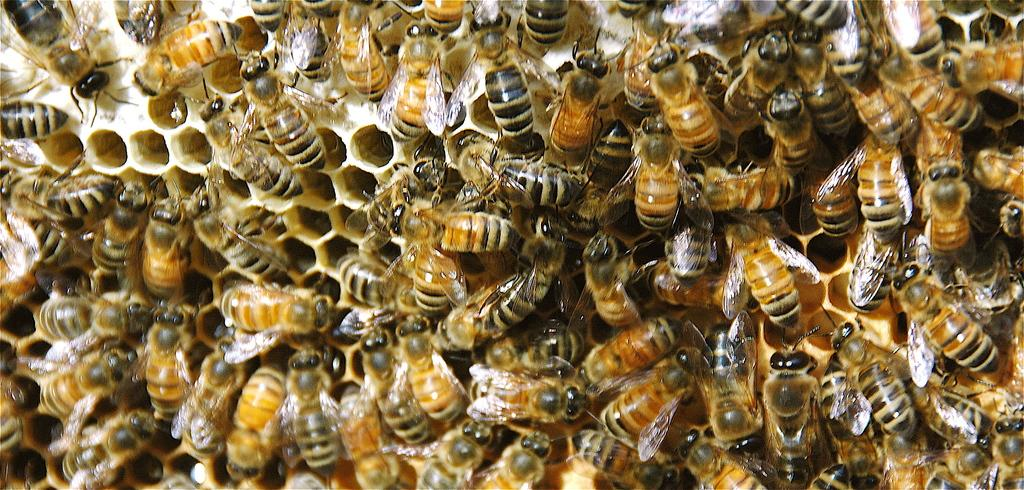What is the main subject of the image? The main subject of the image is a bee hive. Are there any insects visible in the image? Yes, there are honey bees present on the bee hive. How far away is the sun from the bee hive in the image? The sun is not present in the image, so it is not possible to determine its distance from the bee hive. 